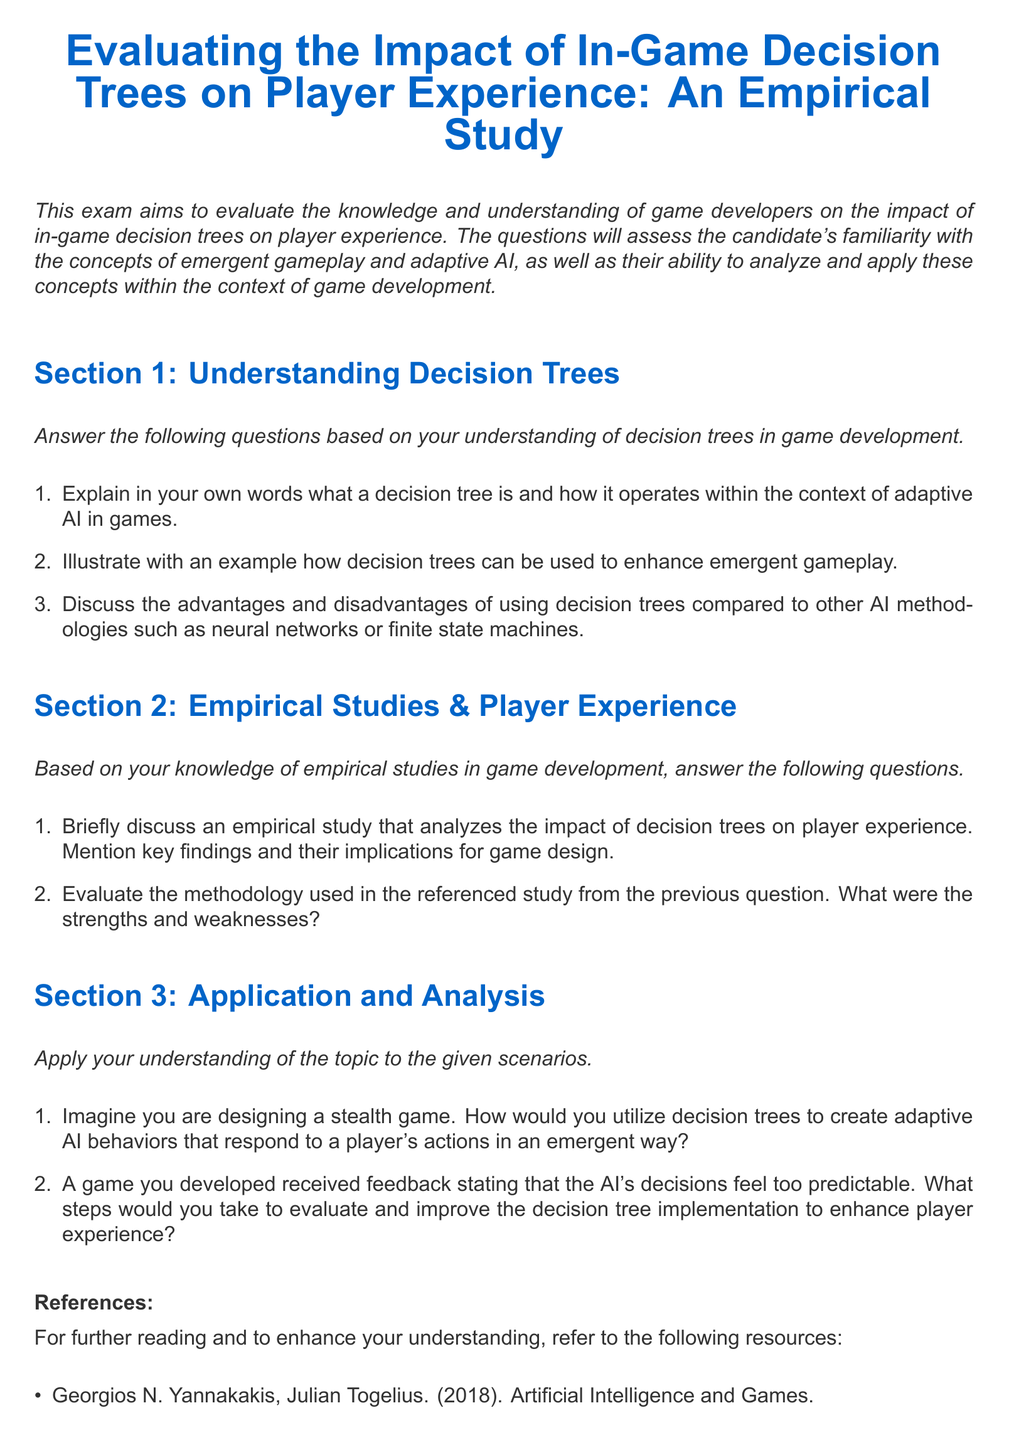What is the title of the exam? The title of the exam is explicitly stated in the document.
Answer: Evaluating the Impact of In-Game Decision Trees on Player Experience: An Empirical Study How many sections are in the exam? The exam is divided into distinct parts, which are clearly numbered in the document.
Answer: Three What color is used for section titles? The document specifies a particular color used for section titles within its formatting.
Answer: Gamer blue Who are the authors mentioned in the references? The document lists specific authors who contributed to the referenced resources.
Answer: Georgios N. Yannakakis, Julian Togelius, Steven Rabin, Anthony M. L. Williams, Joseph A. Bonneau What is the main goal of the exam? The document states this goal at the beginning, emphasizing the primary focus of the assessment.
Answer: To evaluate the knowledge and understanding of game developers What is one example of an area assessed in Section 1? Section 1 contains specific topics that test the candidates’ knowledge about decision trees in game development.
Answer: Understanding Decision Trees What year was the book "Artificial Intelligence and Games" published? The document provides publication years for the references listed.
Answer: 2018 What methodology does Section 2 ask the candidate to evaluate? This section prompts candidates to assess a specific aspect of a referenced study related to decision trees.
Answer: Methodology used in the referenced study In what scenario does Section 3 require application of decision trees? The questions in Section 3 are framed around particular game design situations.
Answer: Designing a stealth game 